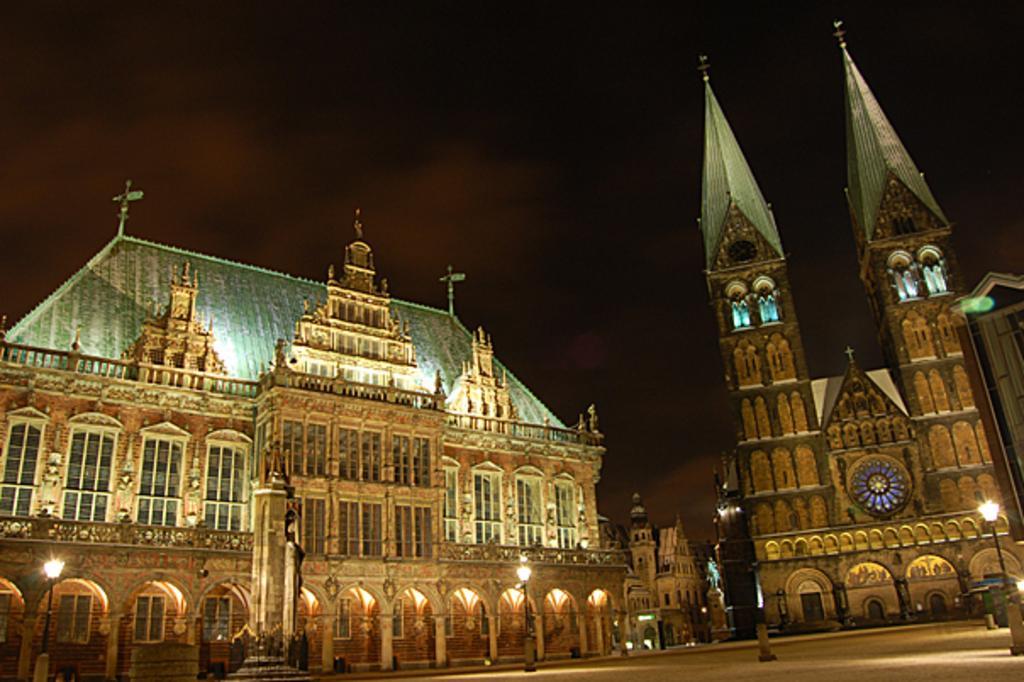How would you summarize this image in a sentence or two? In this picture, we see two churches. Beside that, we see a building. Beside the church, we see street lights. At the bottom of the picture, we see a staircase and street lights. At the top of the picture, it is black in color. This picture is clicked in the dark. 